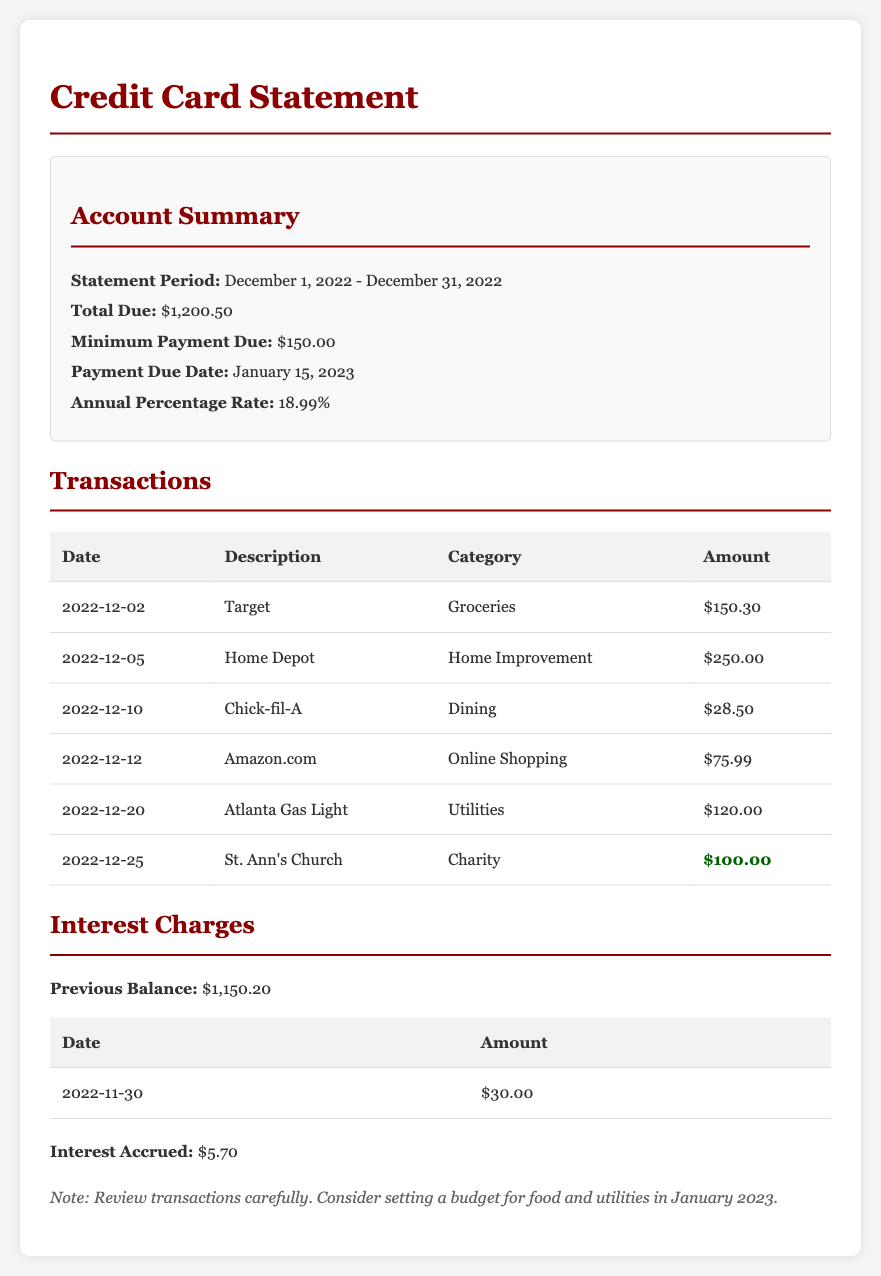What is the statement period? The statement period indicates the dates the credit card transactions cover, which is December 1, 2022 - December 31, 2022.
Answer: December 1, 2022 - December 31, 2022 What is the total due amount? The total due is the full amount that must be paid in the current billing cycle, which is $1,200.50.
Answer: $1,200.50 What is the minimum payment due? The minimum payment due is the smallest amount that needs to be paid to avoid penalties, which is $150.00.
Answer: $150.00 How much was spent at St. Ann's Church? The amount spent at St. Ann's Church is listed as $100.00 under the charity category.
Answer: $100.00 What is the accrued interest for this statement? The accrued interest is the additional charge for borrowing money on the credit card, which is $5.70.
Answer: $5.70 Which transaction category has the highest amount? Analyzing the transactions, the home improvement category has the highest amount charged at $250.00.
Answer: Home Improvement When is the payment due date? The payment due date is the last day on which a payment must be made to avoid penalties, specified as January 15, 2023.
Answer: January 15, 2023 What is the annual percentage rate? The annual percentage rate (APR) represents the cost of borrowing on an annual basis, which is 18.99%.
Answer: 18.99% What was the previous balance? The previous balance shows the amount owed before this statement, which is $1,150.20.
Answer: $1,150.20 